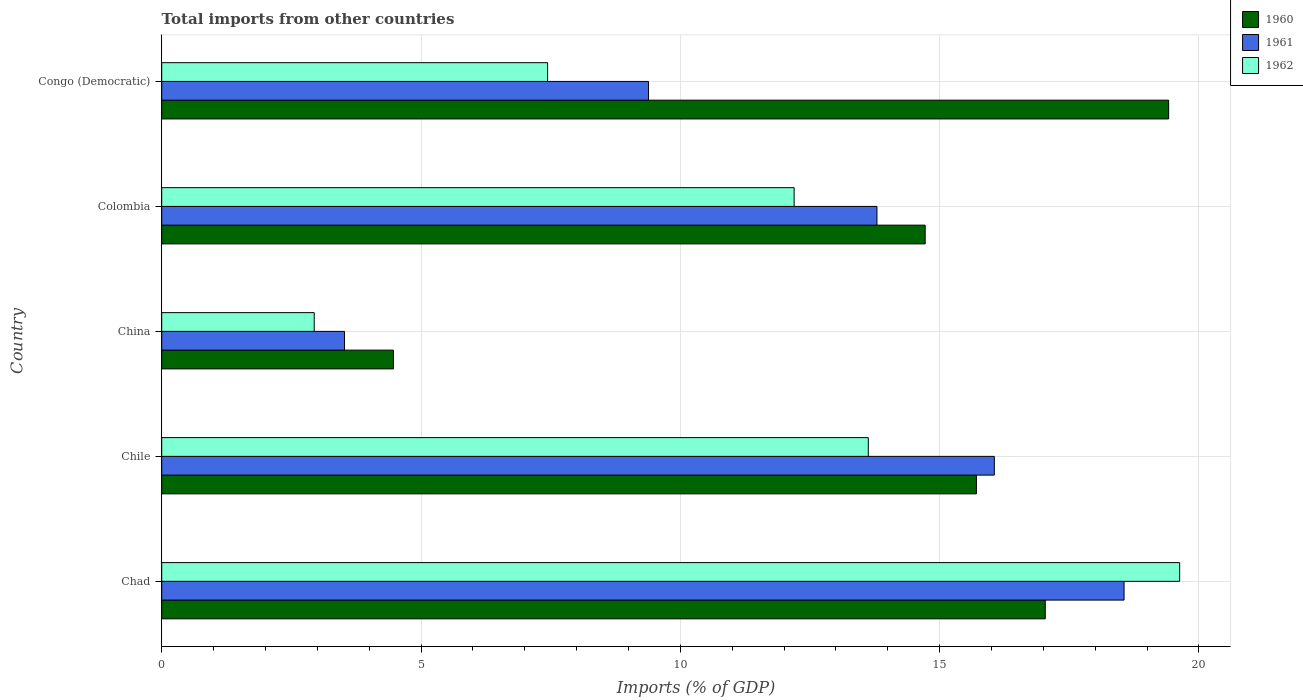How many groups of bars are there?
Provide a short and direct response. 5. Are the number of bars per tick equal to the number of legend labels?
Your answer should be compact. Yes. Are the number of bars on each tick of the Y-axis equal?
Your answer should be very brief. Yes. What is the label of the 5th group of bars from the top?
Make the answer very short. Chad. What is the total imports in 1960 in Chad?
Provide a short and direct response. 17.04. Across all countries, what is the maximum total imports in 1960?
Provide a short and direct response. 19.42. Across all countries, what is the minimum total imports in 1961?
Provide a short and direct response. 3.52. In which country was the total imports in 1960 maximum?
Your answer should be compact. Congo (Democratic). What is the total total imports in 1962 in the graph?
Make the answer very short. 55.83. What is the difference between the total imports in 1962 in Chad and that in Congo (Democratic)?
Offer a very short reply. 12.19. What is the difference between the total imports in 1961 in China and the total imports in 1960 in Chile?
Make the answer very short. -12.19. What is the average total imports in 1961 per country?
Keep it short and to the point. 12.26. What is the difference between the total imports in 1960 and total imports in 1962 in Chad?
Your answer should be compact. -2.59. In how many countries, is the total imports in 1962 greater than 16 %?
Ensure brevity in your answer.  1. What is the ratio of the total imports in 1960 in Colombia to that in Congo (Democratic)?
Offer a very short reply. 0.76. What is the difference between the highest and the second highest total imports in 1961?
Keep it short and to the point. 2.5. What is the difference between the highest and the lowest total imports in 1960?
Provide a short and direct response. 14.95. In how many countries, is the total imports in 1961 greater than the average total imports in 1961 taken over all countries?
Ensure brevity in your answer.  3. What does the 2nd bar from the top in Chile represents?
Offer a very short reply. 1961. What does the 1st bar from the bottom in Colombia represents?
Ensure brevity in your answer.  1960. Is it the case that in every country, the sum of the total imports in 1960 and total imports in 1962 is greater than the total imports in 1961?
Your answer should be compact. Yes. How many bars are there?
Make the answer very short. 15. Are all the bars in the graph horizontal?
Offer a terse response. Yes. What is the difference between two consecutive major ticks on the X-axis?
Your answer should be very brief. 5. Are the values on the major ticks of X-axis written in scientific E-notation?
Your response must be concise. No. Does the graph contain grids?
Ensure brevity in your answer.  Yes. Where does the legend appear in the graph?
Your answer should be very brief. Top right. What is the title of the graph?
Your response must be concise. Total imports from other countries. Does "1992" appear as one of the legend labels in the graph?
Provide a succinct answer. No. What is the label or title of the X-axis?
Give a very brief answer. Imports (% of GDP). What is the Imports (% of GDP) in 1960 in Chad?
Make the answer very short. 17.04. What is the Imports (% of GDP) of 1961 in Chad?
Your answer should be very brief. 18.56. What is the Imports (% of GDP) in 1962 in Chad?
Provide a short and direct response. 19.63. What is the Imports (% of GDP) in 1960 in Chile?
Make the answer very short. 15.71. What is the Imports (% of GDP) of 1961 in Chile?
Provide a succinct answer. 16.06. What is the Imports (% of GDP) in 1962 in Chile?
Your answer should be very brief. 13.62. What is the Imports (% of GDP) in 1960 in China?
Your response must be concise. 4.47. What is the Imports (% of GDP) in 1961 in China?
Give a very brief answer. 3.52. What is the Imports (% of GDP) in 1962 in China?
Your response must be concise. 2.94. What is the Imports (% of GDP) of 1960 in Colombia?
Make the answer very short. 14.72. What is the Imports (% of GDP) in 1961 in Colombia?
Give a very brief answer. 13.79. What is the Imports (% of GDP) of 1962 in Colombia?
Keep it short and to the point. 12.2. What is the Imports (% of GDP) in 1960 in Congo (Democratic)?
Make the answer very short. 19.42. What is the Imports (% of GDP) in 1961 in Congo (Democratic)?
Your answer should be compact. 9.39. What is the Imports (% of GDP) of 1962 in Congo (Democratic)?
Your answer should be very brief. 7.44. Across all countries, what is the maximum Imports (% of GDP) of 1960?
Give a very brief answer. 19.42. Across all countries, what is the maximum Imports (% of GDP) of 1961?
Offer a very short reply. 18.56. Across all countries, what is the maximum Imports (% of GDP) in 1962?
Give a very brief answer. 19.63. Across all countries, what is the minimum Imports (% of GDP) in 1960?
Your answer should be compact. 4.47. Across all countries, what is the minimum Imports (% of GDP) in 1961?
Ensure brevity in your answer.  3.52. Across all countries, what is the minimum Imports (% of GDP) of 1962?
Give a very brief answer. 2.94. What is the total Imports (% of GDP) in 1960 in the graph?
Offer a very short reply. 71.35. What is the total Imports (% of GDP) of 1961 in the graph?
Your answer should be compact. 61.32. What is the total Imports (% of GDP) of 1962 in the graph?
Make the answer very short. 55.83. What is the difference between the Imports (% of GDP) in 1960 in Chad and that in Chile?
Ensure brevity in your answer.  1.33. What is the difference between the Imports (% of GDP) of 1961 in Chad and that in Chile?
Offer a very short reply. 2.5. What is the difference between the Imports (% of GDP) of 1962 in Chad and that in Chile?
Keep it short and to the point. 6. What is the difference between the Imports (% of GDP) in 1960 in Chad and that in China?
Offer a terse response. 12.57. What is the difference between the Imports (% of GDP) of 1961 in Chad and that in China?
Your answer should be very brief. 15.03. What is the difference between the Imports (% of GDP) of 1962 in Chad and that in China?
Make the answer very short. 16.69. What is the difference between the Imports (% of GDP) of 1960 in Chad and that in Colombia?
Provide a short and direct response. 2.32. What is the difference between the Imports (% of GDP) in 1961 in Chad and that in Colombia?
Provide a short and direct response. 4.76. What is the difference between the Imports (% of GDP) of 1962 in Chad and that in Colombia?
Your answer should be compact. 7.43. What is the difference between the Imports (% of GDP) in 1960 in Chad and that in Congo (Democratic)?
Your answer should be very brief. -2.38. What is the difference between the Imports (% of GDP) of 1961 in Chad and that in Congo (Democratic)?
Offer a terse response. 9.17. What is the difference between the Imports (% of GDP) in 1962 in Chad and that in Congo (Democratic)?
Provide a short and direct response. 12.19. What is the difference between the Imports (% of GDP) in 1960 in Chile and that in China?
Offer a terse response. 11.24. What is the difference between the Imports (% of GDP) of 1961 in Chile and that in China?
Offer a terse response. 12.53. What is the difference between the Imports (% of GDP) in 1962 in Chile and that in China?
Your answer should be compact. 10.68. What is the difference between the Imports (% of GDP) in 1961 in Chile and that in Colombia?
Give a very brief answer. 2.26. What is the difference between the Imports (% of GDP) of 1962 in Chile and that in Colombia?
Make the answer very short. 1.43. What is the difference between the Imports (% of GDP) of 1960 in Chile and that in Congo (Democratic)?
Provide a succinct answer. -3.71. What is the difference between the Imports (% of GDP) of 1961 in Chile and that in Congo (Democratic)?
Offer a very short reply. 6.67. What is the difference between the Imports (% of GDP) in 1962 in Chile and that in Congo (Democratic)?
Your answer should be very brief. 6.18. What is the difference between the Imports (% of GDP) in 1960 in China and that in Colombia?
Ensure brevity in your answer.  -10.25. What is the difference between the Imports (% of GDP) in 1961 in China and that in Colombia?
Provide a succinct answer. -10.27. What is the difference between the Imports (% of GDP) of 1962 in China and that in Colombia?
Your answer should be very brief. -9.25. What is the difference between the Imports (% of GDP) of 1960 in China and that in Congo (Democratic)?
Ensure brevity in your answer.  -14.95. What is the difference between the Imports (% of GDP) in 1961 in China and that in Congo (Democratic)?
Your answer should be very brief. -5.86. What is the difference between the Imports (% of GDP) of 1962 in China and that in Congo (Democratic)?
Ensure brevity in your answer.  -4.5. What is the difference between the Imports (% of GDP) in 1960 in Colombia and that in Congo (Democratic)?
Give a very brief answer. -4.7. What is the difference between the Imports (% of GDP) in 1961 in Colombia and that in Congo (Democratic)?
Make the answer very short. 4.4. What is the difference between the Imports (% of GDP) of 1962 in Colombia and that in Congo (Democratic)?
Offer a terse response. 4.75. What is the difference between the Imports (% of GDP) of 1960 in Chad and the Imports (% of GDP) of 1961 in Chile?
Offer a very short reply. 0.98. What is the difference between the Imports (% of GDP) of 1960 in Chad and the Imports (% of GDP) of 1962 in Chile?
Provide a succinct answer. 3.41. What is the difference between the Imports (% of GDP) in 1961 in Chad and the Imports (% of GDP) in 1962 in Chile?
Your answer should be compact. 4.93. What is the difference between the Imports (% of GDP) of 1960 in Chad and the Imports (% of GDP) of 1961 in China?
Your answer should be compact. 13.51. What is the difference between the Imports (% of GDP) of 1960 in Chad and the Imports (% of GDP) of 1962 in China?
Keep it short and to the point. 14.1. What is the difference between the Imports (% of GDP) in 1961 in Chad and the Imports (% of GDP) in 1962 in China?
Your answer should be compact. 15.62. What is the difference between the Imports (% of GDP) in 1960 in Chad and the Imports (% of GDP) in 1961 in Colombia?
Offer a terse response. 3.25. What is the difference between the Imports (% of GDP) of 1960 in Chad and the Imports (% of GDP) of 1962 in Colombia?
Your answer should be very brief. 4.84. What is the difference between the Imports (% of GDP) in 1961 in Chad and the Imports (% of GDP) in 1962 in Colombia?
Your answer should be very brief. 6.36. What is the difference between the Imports (% of GDP) of 1960 in Chad and the Imports (% of GDP) of 1961 in Congo (Democratic)?
Provide a short and direct response. 7.65. What is the difference between the Imports (% of GDP) in 1960 in Chad and the Imports (% of GDP) in 1962 in Congo (Democratic)?
Offer a very short reply. 9.6. What is the difference between the Imports (% of GDP) in 1961 in Chad and the Imports (% of GDP) in 1962 in Congo (Democratic)?
Your response must be concise. 11.12. What is the difference between the Imports (% of GDP) of 1960 in Chile and the Imports (% of GDP) of 1961 in China?
Provide a short and direct response. 12.19. What is the difference between the Imports (% of GDP) of 1960 in Chile and the Imports (% of GDP) of 1962 in China?
Your answer should be very brief. 12.77. What is the difference between the Imports (% of GDP) in 1961 in Chile and the Imports (% of GDP) in 1962 in China?
Keep it short and to the point. 13.11. What is the difference between the Imports (% of GDP) of 1960 in Chile and the Imports (% of GDP) of 1961 in Colombia?
Give a very brief answer. 1.92. What is the difference between the Imports (% of GDP) in 1960 in Chile and the Imports (% of GDP) in 1962 in Colombia?
Your answer should be very brief. 3.51. What is the difference between the Imports (% of GDP) of 1961 in Chile and the Imports (% of GDP) of 1962 in Colombia?
Your response must be concise. 3.86. What is the difference between the Imports (% of GDP) in 1960 in Chile and the Imports (% of GDP) in 1961 in Congo (Democratic)?
Your response must be concise. 6.32. What is the difference between the Imports (% of GDP) in 1960 in Chile and the Imports (% of GDP) in 1962 in Congo (Democratic)?
Offer a terse response. 8.27. What is the difference between the Imports (% of GDP) of 1961 in Chile and the Imports (% of GDP) of 1962 in Congo (Democratic)?
Offer a terse response. 8.61. What is the difference between the Imports (% of GDP) in 1960 in China and the Imports (% of GDP) in 1961 in Colombia?
Provide a succinct answer. -9.32. What is the difference between the Imports (% of GDP) of 1960 in China and the Imports (% of GDP) of 1962 in Colombia?
Offer a terse response. -7.73. What is the difference between the Imports (% of GDP) in 1961 in China and the Imports (% of GDP) in 1962 in Colombia?
Provide a short and direct response. -8.67. What is the difference between the Imports (% of GDP) of 1960 in China and the Imports (% of GDP) of 1961 in Congo (Democratic)?
Your response must be concise. -4.92. What is the difference between the Imports (% of GDP) of 1960 in China and the Imports (% of GDP) of 1962 in Congo (Democratic)?
Your answer should be very brief. -2.97. What is the difference between the Imports (% of GDP) of 1961 in China and the Imports (% of GDP) of 1962 in Congo (Democratic)?
Ensure brevity in your answer.  -3.92. What is the difference between the Imports (% of GDP) of 1960 in Colombia and the Imports (% of GDP) of 1961 in Congo (Democratic)?
Your response must be concise. 5.33. What is the difference between the Imports (% of GDP) in 1960 in Colombia and the Imports (% of GDP) in 1962 in Congo (Democratic)?
Your answer should be very brief. 7.28. What is the difference between the Imports (% of GDP) in 1961 in Colombia and the Imports (% of GDP) in 1962 in Congo (Democratic)?
Make the answer very short. 6.35. What is the average Imports (% of GDP) of 1960 per country?
Your response must be concise. 14.27. What is the average Imports (% of GDP) in 1961 per country?
Ensure brevity in your answer.  12.26. What is the average Imports (% of GDP) of 1962 per country?
Ensure brevity in your answer.  11.17. What is the difference between the Imports (% of GDP) in 1960 and Imports (% of GDP) in 1961 in Chad?
Your answer should be very brief. -1.52. What is the difference between the Imports (% of GDP) of 1960 and Imports (% of GDP) of 1962 in Chad?
Offer a terse response. -2.59. What is the difference between the Imports (% of GDP) in 1961 and Imports (% of GDP) in 1962 in Chad?
Offer a terse response. -1.07. What is the difference between the Imports (% of GDP) in 1960 and Imports (% of GDP) in 1961 in Chile?
Ensure brevity in your answer.  -0.35. What is the difference between the Imports (% of GDP) of 1960 and Imports (% of GDP) of 1962 in Chile?
Provide a succinct answer. 2.08. What is the difference between the Imports (% of GDP) in 1961 and Imports (% of GDP) in 1962 in Chile?
Give a very brief answer. 2.43. What is the difference between the Imports (% of GDP) of 1960 and Imports (% of GDP) of 1961 in China?
Provide a short and direct response. 0.94. What is the difference between the Imports (% of GDP) of 1960 and Imports (% of GDP) of 1962 in China?
Make the answer very short. 1.53. What is the difference between the Imports (% of GDP) in 1961 and Imports (% of GDP) in 1962 in China?
Offer a terse response. 0.58. What is the difference between the Imports (% of GDP) in 1960 and Imports (% of GDP) in 1961 in Colombia?
Your answer should be compact. 0.93. What is the difference between the Imports (% of GDP) of 1960 and Imports (% of GDP) of 1962 in Colombia?
Give a very brief answer. 2.53. What is the difference between the Imports (% of GDP) of 1961 and Imports (% of GDP) of 1962 in Colombia?
Your response must be concise. 1.6. What is the difference between the Imports (% of GDP) in 1960 and Imports (% of GDP) in 1961 in Congo (Democratic)?
Provide a short and direct response. 10.03. What is the difference between the Imports (% of GDP) in 1960 and Imports (% of GDP) in 1962 in Congo (Democratic)?
Provide a short and direct response. 11.98. What is the difference between the Imports (% of GDP) in 1961 and Imports (% of GDP) in 1962 in Congo (Democratic)?
Your answer should be very brief. 1.95. What is the ratio of the Imports (% of GDP) of 1960 in Chad to that in Chile?
Make the answer very short. 1.08. What is the ratio of the Imports (% of GDP) of 1961 in Chad to that in Chile?
Offer a very short reply. 1.16. What is the ratio of the Imports (% of GDP) in 1962 in Chad to that in Chile?
Your response must be concise. 1.44. What is the ratio of the Imports (% of GDP) in 1960 in Chad to that in China?
Provide a short and direct response. 3.81. What is the ratio of the Imports (% of GDP) of 1961 in Chad to that in China?
Your answer should be compact. 5.26. What is the ratio of the Imports (% of GDP) of 1962 in Chad to that in China?
Give a very brief answer. 6.67. What is the ratio of the Imports (% of GDP) of 1960 in Chad to that in Colombia?
Provide a short and direct response. 1.16. What is the ratio of the Imports (% of GDP) of 1961 in Chad to that in Colombia?
Provide a short and direct response. 1.35. What is the ratio of the Imports (% of GDP) of 1962 in Chad to that in Colombia?
Your answer should be very brief. 1.61. What is the ratio of the Imports (% of GDP) of 1960 in Chad to that in Congo (Democratic)?
Offer a very short reply. 0.88. What is the ratio of the Imports (% of GDP) in 1961 in Chad to that in Congo (Democratic)?
Ensure brevity in your answer.  1.98. What is the ratio of the Imports (% of GDP) in 1962 in Chad to that in Congo (Democratic)?
Keep it short and to the point. 2.64. What is the ratio of the Imports (% of GDP) of 1960 in Chile to that in China?
Make the answer very short. 3.52. What is the ratio of the Imports (% of GDP) in 1961 in Chile to that in China?
Offer a very short reply. 4.56. What is the ratio of the Imports (% of GDP) in 1962 in Chile to that in China?
Provide a short and direct response. 4.63. What is the ratio of the Imports (% of GDP) in 1960 in Chile to that in Colombia?
Your answer should be compact. 1.07. What is the ratio of the Imports (% of GDP) of 1961 in Chile to that in Colombia?
Your answer should be very brief. 1.16. What is the ratio of the Imports (% of GDP) in 1962 in Chile to that in Colombia?
Offer a very short reply. 1.12. What is the ratio of the Imports (% of GDP) in 1960 in Chile to that in Congo (Democratic)?
Offer a terse response. 0.81. What is the ratio of the Imports (% of GDP) in 1961 in Chile to that in Congo (Democratic)?
Provide a short and direct response. 1.71. What is the ratio of the Imports (% of GDP) in 1962 in Chile to that in Congo (Democratic)?
Your answer should be compact. 1.83. What is the ratio of the Imports (% of GDP) of 1960 in China to that in Colombia?
Give a very brief answer. 0.3. What is the ratio of the Imports (% of GDP) in 1961 in China to that in Colombia?
Offer a terse response. 0.26. What is the ratio of the Imports (% of GDP) of 1962 in China to that in Colombia?
Your answer should be very brief. 0.24. What is the ratio of the Imports (% of GDP) of 1960 in China to that in Congo (Democratic)?
Provide a succinct answer. 0.23. What is the ratio of the Imports (% of GDP) of 1961 in China to that in Congo (Democratic)?
Your response must be concise. 0.38. What is the ratio of the Imports (% of GDP) of 1962 in China to that in Congo (Democratic)?
Your response must be concise. 0.4. What is the ratio of the Imports (% of GDP) of 1960 in Colombia to that in Congo (Democratic)?
Give a very brief answer. 0.76. What is the ratio of the Imports (% of GDP) of 1961 in Colombia to that in Congo (Democratic)?
Offer a very short reply. 1.47. What is the ratio of the Imports (% of GDP) in 1962 in Colombia to that in Congo (Democratic)?
Offer a terse response. 1.64. What is the difference between the highest and the second highest Imports (% of GDP) of 1960?
Offer a very short reply. 2.38. What is the difference between the highest and the second highest Imports (% of GDP) in 1961?
Keep it short and to the point. 2.5. What is the difference between the highest and the second highest Imports (% of GDP) of 1962?
Give a very brief answer. 6. What is the difference between the highest and the lowest Imports (% of GDP) of 1960?
Your answer should be very brief. 14.95. What is the difference between the highest and the lowest Imports (% of GDP) in 1961?
Offer a very short reply. 15.03. What is the difference between the highest and the lowest Imports (% of GDP) of 1962?
Give a very brief answer. 16.69. 